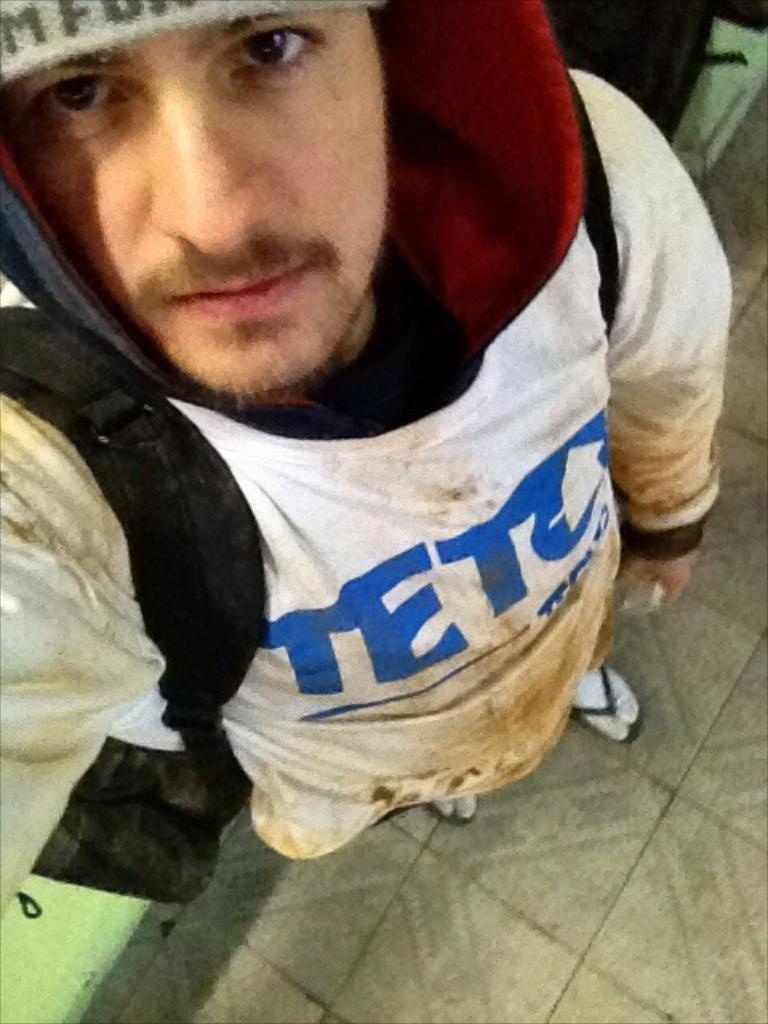<image>
Summarize the visual content of the image. a man that has the word teto on his shirt 